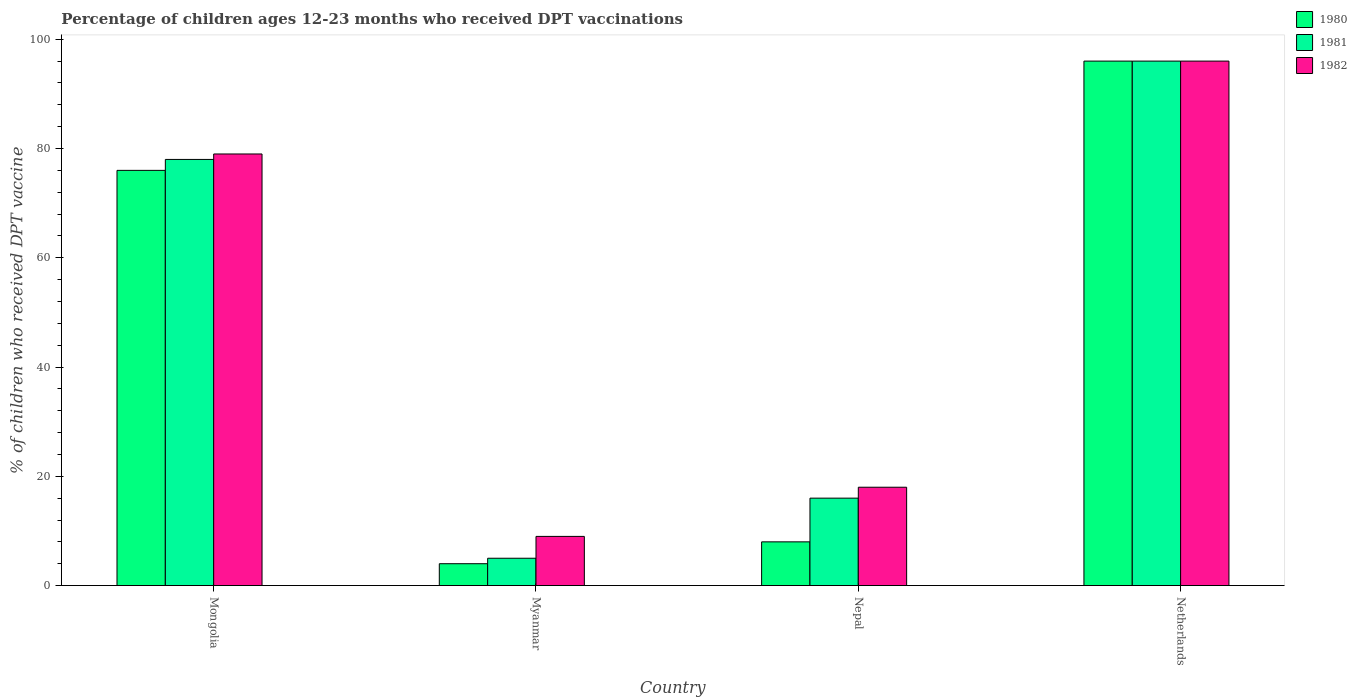How many groups of bars are there?
Provide a succinct answer. 4. How many bars are there on the 3rd tick from the right?
Provide a short and direct response. 3. What is the label of the 1st group of bars from the left?
Provide a short and direct response. Mongolia. Across all countries, what is the maximum percentage of children who received DPT vaccination in 1980?
Your answer should be very brief. 96. Across all countries, what is the minimum percentage of children who received DPT vaccination in 1982?
Provide a short and direct response. 9. In which country was the percentage of children who received DPT vaccination in 1982 minimum?
Make the answer very short. Myanmar. What is the total percentage of children who received DPT vaccination in 1980 in the graph?
Make the answer very short. 184. What is the difference between the percentage of children who received DPT vaccination in 1982 in Nepal and that in Netherlands?
Make the answer very short. -78. What is the difference between the percentage of children who received DPT vaccination in 1980 in Myanmar and the percentage of children who received DPT vaccination in 1982 in Mongolia?
Offer a very short reply. -75. What is the average percentage of children who received DPT vaccination in 1981 per country?
Give a very brief answer. 48.75. What is the difference between the percentage of children who received DPT vaccination of/in 1982 and percentage of children who received DPT vaccination of/in 1980 in Myanmar?
Offer a terse response. 5. In how many countries, is the percentage of children who received DPT vaccination in 1982 greater than 44 %?
Offer a very short reply. 2. What is the ratio of the percentage of children who received DPT vaccination in 1982 in Nepal to that in Netherlands?
Your answer should be very brief. 0.19. Is the difference between the percentage of children who received DPT vaccination in 1982 in Nepal and Netherlands greater than the difference between the percentage of children who received DPT vaccination in 1980 in Nepal and Netherlands?
Keep it short and to the point. Yes. What is the difference between the highest and the second highest percentage of children who received DPT vaccination in 1980?
Keep it short and to the point. 88. What is the difference between the highest and the lowest percentage of children who received DPT vaccination in 1981?
Keep it short and to the point. 91. In how many countries, is the percentage of children who received DPT vaccination in 1982 greater than the average percentage of children who received DPT vaccination in 1982 taken over all countries?
Ensure brevity in your answer.  2. What does the 3rd bar from the right in Netherlands represents?
Offer a terse response. 1980. How many bars are there?
Provide a succinct answer. 12. Are all the bars in the graph horizontal?
Keep it short and to the point. No. How many countries are there in the graph?
Make the answer very short. 4. What is the difference between two consecutive major ticks on the Y-axis?
Provide a succinct answer. 20. Are the values on the major ticks of Y-axis written in scientific E-notation?
Give a very brief answer. No. Does the graph contain any zero values?
Your answer should be compact. No. Where does the legend appear in the graph?
Keep it short and to the point. Top right. What is the title of the graph?
Offer a very short reply. Percentage of children ages 12-23 months who received DPT vaccinations. Does "1973" appear as one of the legend labels in the graph?
Your response must be concise. No. What is the label or title of the X-axis?
Ensure brevity in your answer.  Country. What is the label or title of the Y-axis?
Keep it short and to the point. % of children who received DPT vaccine. What is the % of children who received DPT vaccine of 1982 in Mongolia?
Offer a terse response. 79. What is the % of children who received DPT vaccine of 1980 in Myanmar?
Offer a very short reply. 4. What is the % of children who received DPT vaccine of 1982 in Myanmar?
Offer a very short reply. 9. What is the % of children who received DPT vaccine of 1981 in Nepal?
Offer a very short reply. 16. What is the % of children who received DPT vaccine of 1982 in Nepal?
Your answer should be compact. 18. What is the % of children who received DPT vaccine in 1980 in Netherlands?
Provide a succinct answer. 96. What is the % of children who received DPT vaccine in 1981 in Netherlands?
Give a very brief answer. 96. What is the % of children who received DPT vaccine in 1982 in Netherlands?
Offer a very short reply. 96. Across all countries, what is the maximum % of children who received DPT vaccine in 1980?
Give a very brief answer. 96. Across all countries, what is the maximum % of children who received DPT vaccine in 1981?
Keep it short and to the point. 96. Across all countries, what is the maximum % of children who received DPT vaccine in 1982?
Give a very brief answer. 96. Across all countries, what is the minimum % of children who received DPT vaccine in 1980?
Your response must be concise. 4. Across all countries, what is the minimum % of children who received DPT vaccine in 1981?
Your answer should be very brief. 5. What is the total % of children who received DPT vaccine of 1980 in the graph?
Make the answer very short. 184. What is the total % of children who received DPT vaccine of 1981 in the graph?
Your response must be concise. 195. What is the total % of children who received DPT vaccine of 1982 in the graph?
Offer a terse response. 202. What is the difference between the % of children who received DPT vaccine in 1980 in Mongolia and that in Myanmar?
Provide a succinct answer. 72. What is the difference between the % of children who received DPT vaccine in 1981 in Mongolia and that in Myanmar?
Your answer should be compact. 73. What is the difference between the % of children who received DPT vaccine of 1982 in Mongolia and that in Nepal?
Your response must be concise. 61. What is the difference between the % of children who received DPT vaccine of 1980 in Mongolia and that in Netherlands?
Give a very brief answer. -20. What is the difference between the % of children who received DPT vaccine in 1981 in Mongolia and that in Netherlands?
Give a very brief answer. -18. What is the difference between the % of children who received DPT vaccine in 1980 in Myanmar and that in Nepal?
Your answer should be very brief. -4. What is the difference between the % of children who received DPT vaccine in 1982 in Myanmar and that in Nepal?
Offer a terse response. -9. What is the difference between the % of children who received DPT vaccine in 1980 in Myanmar and that in Netherlands?
Your answer should be very brief. -92. What is the difference between the % of children who received DPT vaccine of 1981 in Myanmar and that in Netherlands?
Your answer should be very brief. -91. What is the difference between the % of children who received DPT vaccine of 1982 in Myanmar and that in Netherlands?
Your answer should be very brief. -87. What is the difference between the % of children who received DPT vaccine in 1980 in Nepal and that in Netherlands?
Provide a short and direct response. -88. What is the difference between the % of children who received DPT vaccine in 1981 in Nepal and that in Netherlands?
Offer a very short reply. -80. What is the difference between the % of children who received DPT vaccine in 1982 in Nepal and that in Netherlands?
Make the answer very short. -78. What is the difference between the % of children who received DPT vaccine in 1980 in Mongolia and the % of children who received DPT vaccine in 1981 in Myanmar?
Your answer should be compact. 71. What is the difference between the % of children who received DPT vaccine in 1980 in Mongolia and the % of children who received DPT vaccine in 1982 in Myanmar?
Give a very brief answer. 67. What is the difference between the % of children who received DPT vaccine of 1980 in Mongolia and the % of children who received DPT vaccine of 1981 in Nepal?
Your response must be concise. 60. What is the difference between the % of children who received DPT vaccine in 1980 in Mongolia and the % of children who received DPT vaccine in 1982 in Nepal?
Keep it short and to the point. 58. What is the difference between the % of children who received DPT vaccine in 1981 in Mongolia and the % of children who received DPT vaccine in 1982 in Nepal?
Your response must be concise. 60. What is the difference between the % of children who received DPT vaccine in 1981 in Mongolia and the % of children who received DPT vaccine in 1982 in Netherlands?
Offer a very short reply. -18. What is the difference between the % of children who received DPT vaccine in 1981 in Myanmar and the % of children who received DPT vaccine in 1982 in Nepal?
Offer a terse response. -13. What is the difference between the % of children who received DPT vaccine in 1980 in Myanmar and the % of children who received DPT vaccine in 1981 in Netherlands?
Make the answer very short. -92. What is the difference between the % of children who received DPT vaccine of 1980 in Myanmar and the % of children who received DPT vaccine of 1982 in Netherlands?
Offer a terse response. -92. What is the difference between the % of children who received DPT vaccine of 1981 in Myanmar and the % of children who received DPT vaccine of 1982 in Netherlands?
Provide a succinct answer. -91. What is the difference between the % of children who received DPT vaccine of 1980 in Nepal and the % of children who received DPT vaccine of 1981 in Netherlands?
Keep it short and to the point. -88. What is the difference between the % of children who received DPT vaccine of 1980 in Nepal and the % of children who received DPT vaccine of 1982 in Netherlands?
Offer a terse response. -88. What is the difference between the % of children who received DPT vaccine in 1981 in Nepal and the % of children who received DPT vaccine in 1982 in Netherlands?
Your answer should be very brief. -80. What is the average % of children who received DPT vaccine in 1980 per country?
Your response must be concise. 46. What is the average % of children who received DPT vaccine in 1981 per country?
Give a very brief answer. 48.75. What is the average % of children who received DPT vaccine in 1982 per country?
Provide a short and direct response. 50.5. What is the difference between the % of children who received DPT vaccine of 1980 and % of children who received DPT vaccine of 1982 in Mongolia?
Offer a very short reply. -3. What is the difference between the % of children who received DPT vaccine in 1981 and % of children who received DPT vaccine in 1982 in Mongolia?
Provide a short and direct response. -1. What is the difference between the % of children who received DPT vaccine of 1980 and % of children who received DPT vaccine of 1981 in Myanmar?
Provide a short and direct response. -1. What is the difference between the % of children who received DPT vaccine of 1980 and % of children who received DPT vaccine of 1982 in Myanmar?
Provide a short and direct response. -5. What is the difference between the % of children who received DPT vaccine of 1981 and % of children who received DPT vaccine of 1982 in Myanmar?
Your response must be concise. -4. What is the difference between the % of children who received DPT vaccine of 1980 and % of children who received DPT vaccine of 1982 in Nepal?
Provide a short and direct response. -10. What is the difference between the % of children who received DPT vaccine in 1981 and % of children who received DPT vaccine in 1982 in Nepal?
Offer a terse response. -2. What is the ratio of the % of children who received DPT vaccine in 1982 in Mongolia to that in Myanmar?
Offer a very short reply. 8.78. What is the ratio of the % of children who received DPT vaccine in 1981 in Mongolia to that in Nepal?
Provide a succinct answer. 4.88. What is the ratio of the % of children who received DPT vaccine of 1982 in Mongolia to that in Nepal?
Your response must be concise. 4.39. What is the ratio of the % of children who received DPT vaccine of 1980 in Mongolia to that in Netherlands?
Make the answer very short. 0.79. What is the ratio of the % of children who received DPT vaccine of 1981 in Mongolia to that in Netherlands?
Offer a terse response. 0.81. What is the ratio of the % of children who received DPT vaccine of 1982 in Mongolia to that in Netherlands?
Make the answer very short. 0.82. What is the ratio of the % of children who received DPT vaccine of 1980 in Myanmar to that in Nepal?
Provide a succinct answer. 0.5. What is the ratio of the % of children who received DPT vaccine of 1981 in Myanmar to that in Nepal?
Your answer should be compact. 0.31. What is the ratio of the % of children who received DPT vaccine in 1980 in Myanmar to that in Netherlands?
Offer a terse response. 0.04. What is the ratio of the % of children who received DPT vaccine in 1981 in Myanmar to that in Netherlands?
Make the answer very short. 0.05. What is the ratio of the % of children who received DPT vaccine in 1982 in Myanmar to that in Netherlands?
Make the answer very short. 0.09. What is the ratio of the % of children who received DPT vaccine in 1980 in Nepal to that in Netherlands?
Give a very brief answer. 0.08. What is the ratio of the % of children who received DPT vaccine in 1982 in Nepal to that in Netherlands?
Offer a very short reply. 0.19. What is the difference between the highest and the lowest % of children who received DPT vaccine in 1980?
Make the answer very short. 92. What is the difference between the highest and the lowest % of children who received DPT vaccine in 1981?
Offer a very short reply. 91. What is the difference between the highest and the lowest % of children who received DPT vaccine in 1982?
Your answer should be very brief. 87. 